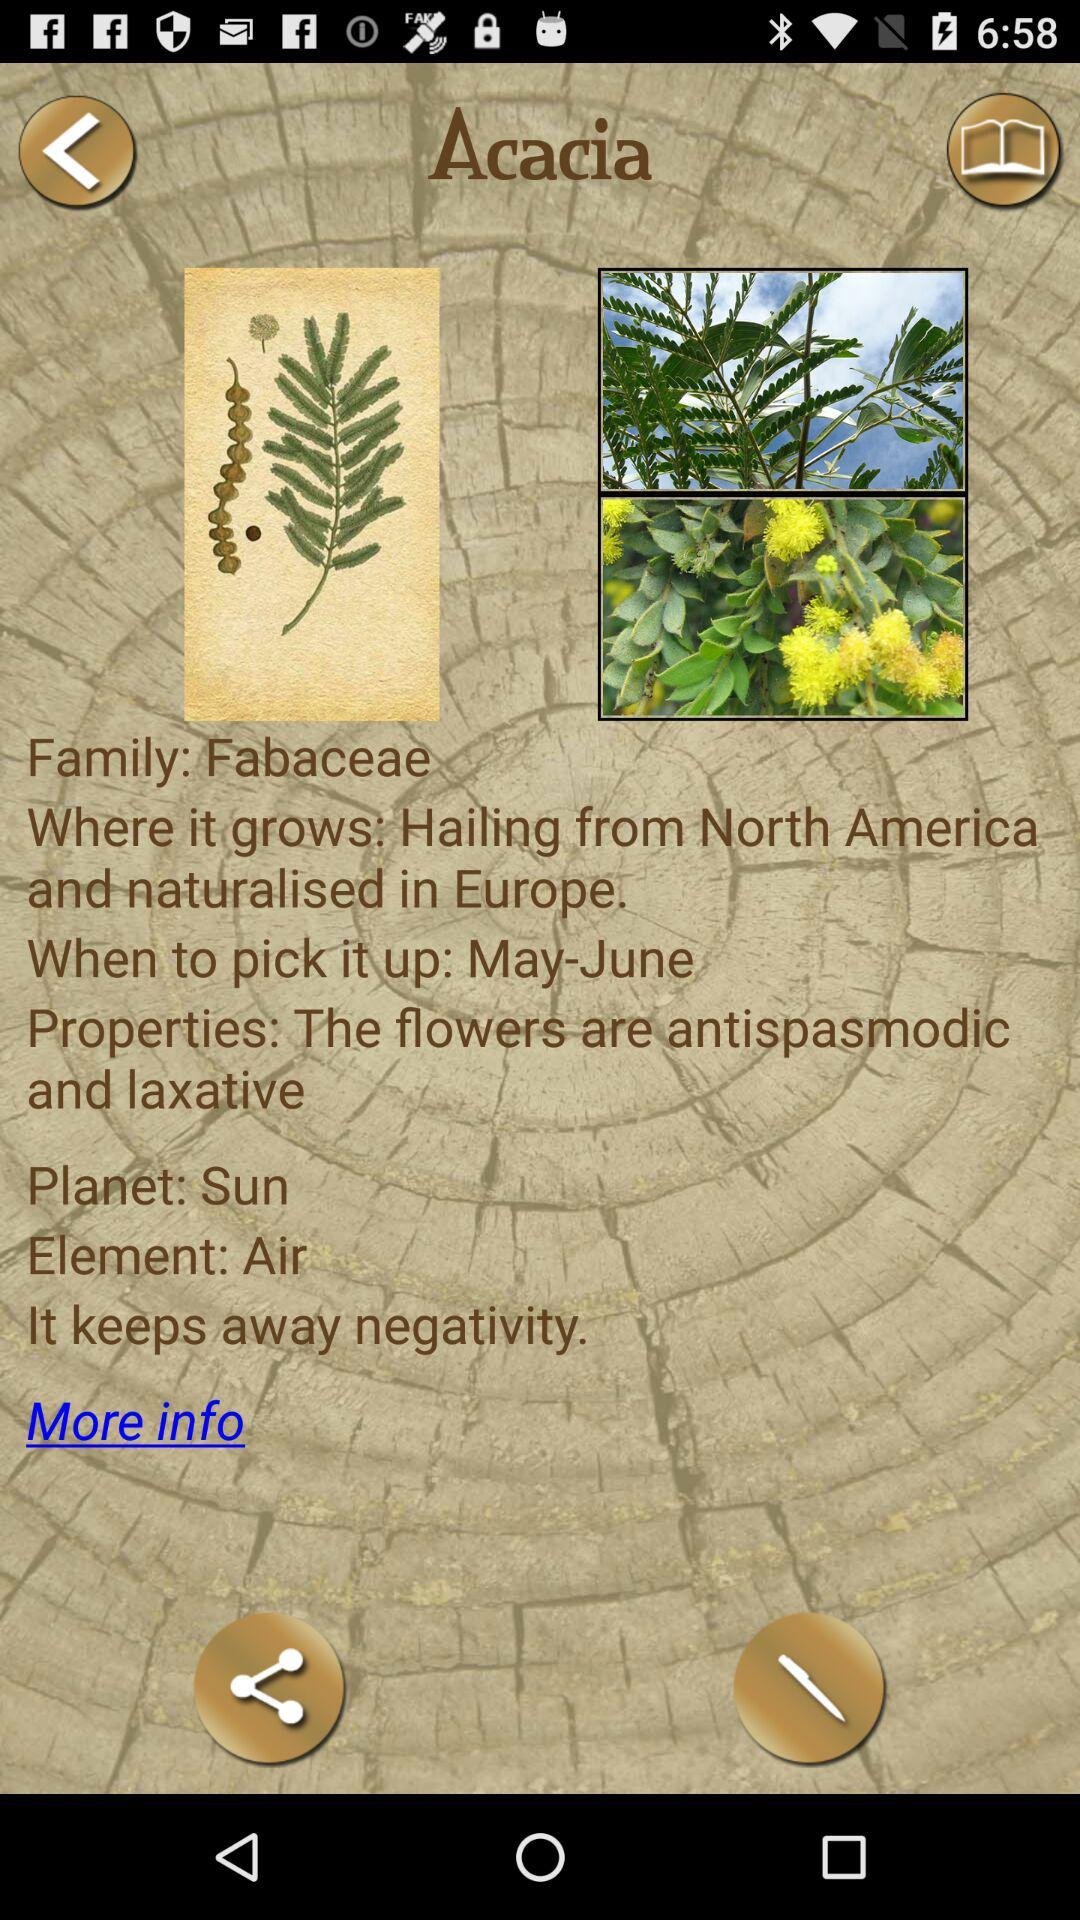What element does Acacia represent? Acacia represents the element of air. 